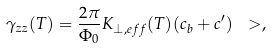Convert formula to latex. <formula><loc_0><loc_0><loc_500><loc_500>\gamma _ { z z } ( T ) = \frac { 2 \pi } { \Phi _ { 0 } } K _ { \perp , e f f } ( T ) ( c _ { b } + c ^ { \prime } ) \ > , \\</formula> 